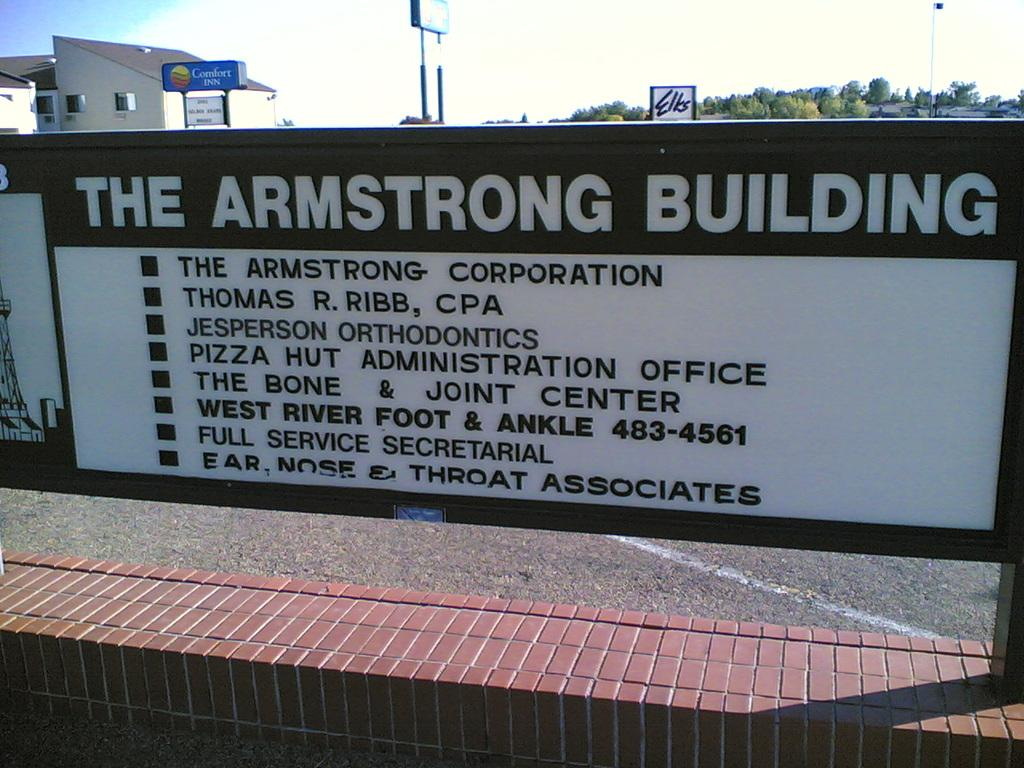<image>
Offer a succinct explanation of the picture presented. A sign lists the various businesses located in the Armstrong Building. 